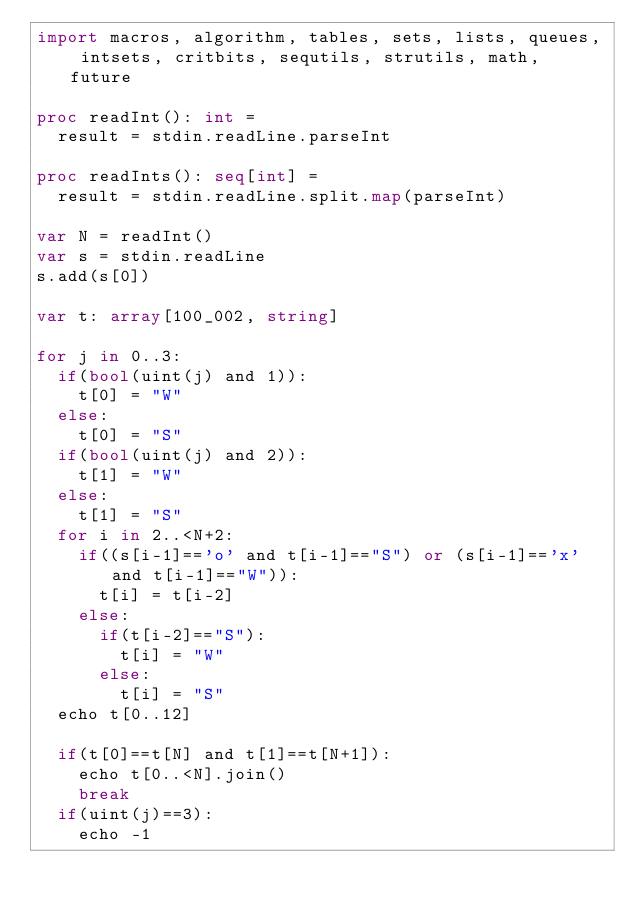<code> <loc_0><loc_0><loc_500><loc_500><_Nim_>import macros, algorithm, tables, sets, lists, queues, intsets, critbits, sequtils, strutils, math, future

proc readInt(): int =
  result = stdin.readLine.parseInt

proc readInts(): seq[int] =
  result = stdin.readLine.split.map(parseInt)

var N = readInt()
var s = stdin.readLine
s.add(s[0])

var t: array[100_002, string]

for j in 0..3:
  if(bool(uint(j) and 1)):
    t[0] = "W"
  else:
    t[0] = "S"
  if(bool(uint(j) and 2)):
    t[1] = "W"
  else:
    t[1] = "S"
  for i in 2..<N+2:
    if((s[i-1]=='o' and t[i-1]=="S") or (s[i-1]=='x' and t[i-1]=="W")):
      t[i] = t[i-2]
    else:
      if(t[i-2]=="S"):
        t[i] = "W"
      else:
        t[i] = "S"
  echo t[0..12]

  if(t[0]==t[N] and t[1]==t[N+1]):
    echo t[0..<N].join()
    break
  if(uint(j)==3):
    echo -1


</code> 